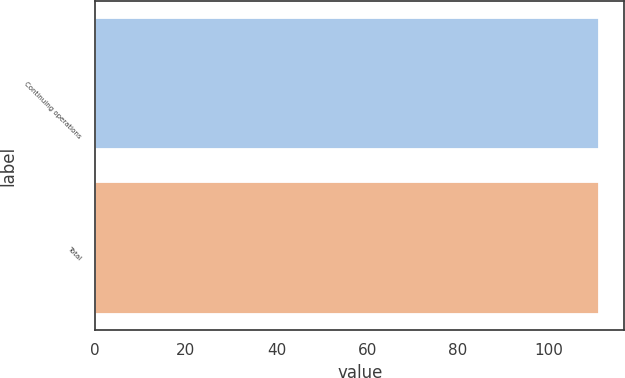Convert chart to OTSL. <chart><loc_0><loc_0><loc_500><loc_500><bar_chart><fcel>Continuing operations<fcel>Total<nl><fcel>111<fcel>111.1<nl></chart> 